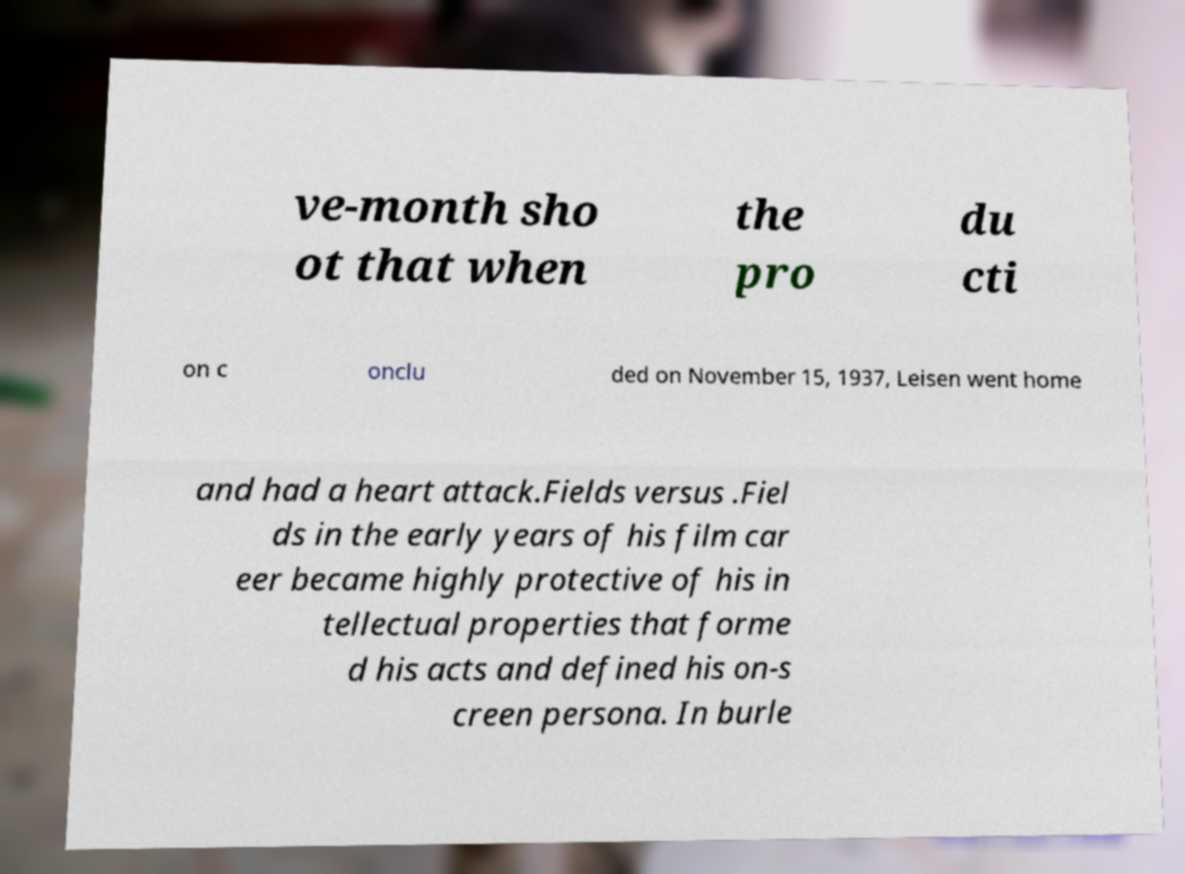I need the written content from this picture converted into text. Can you do that? ve-month sho ot that when the pro du cti on c onclu ded on November 15, 1937, Leisen went home and had a heart attack.Fields versus .Fiel ds in the early years of his film car eer became highly protective of his in tellectual properties that forme d his acts and defined his on-s creen persona. In burle 